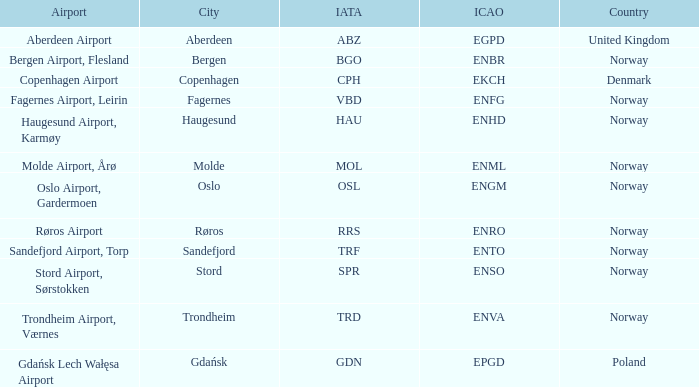What is th IATA for Norway with an ICAO of ENTO? TRF. 